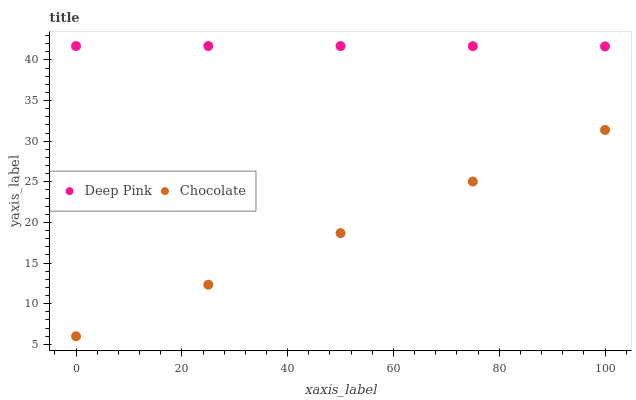Does Chocolate have the minimum area under the curve?
Answer yes or no. Yes. Does Deep Pink have the maximum area under the curve?
Answer yes or no. Yes. Does Chocolate have the maximum area under the curve?
Answer yes or no. No. Is Chocolate the smoothest?
Answer yes or no. Yes. Is Deep Pink the roughest?
Answer yes or no. Yes. Is Chocolate the roughest?
Answer yes or no. No. Does Chocolate have the lowest value?
Answer yes or no. Yes. Does Deep Pink have the highest value?
Answer yes or no. Yes. Does Chocolate have the highest value?
Answer yes or no. No. Is Chocolate less than Deep Pink?
Answer yes or no. Yes. Is Deep Pink greater than Chocolate?
Answer yes or no. Yes. Does Chocolate intersect Deep Pink?
Answer yes or no. No. 